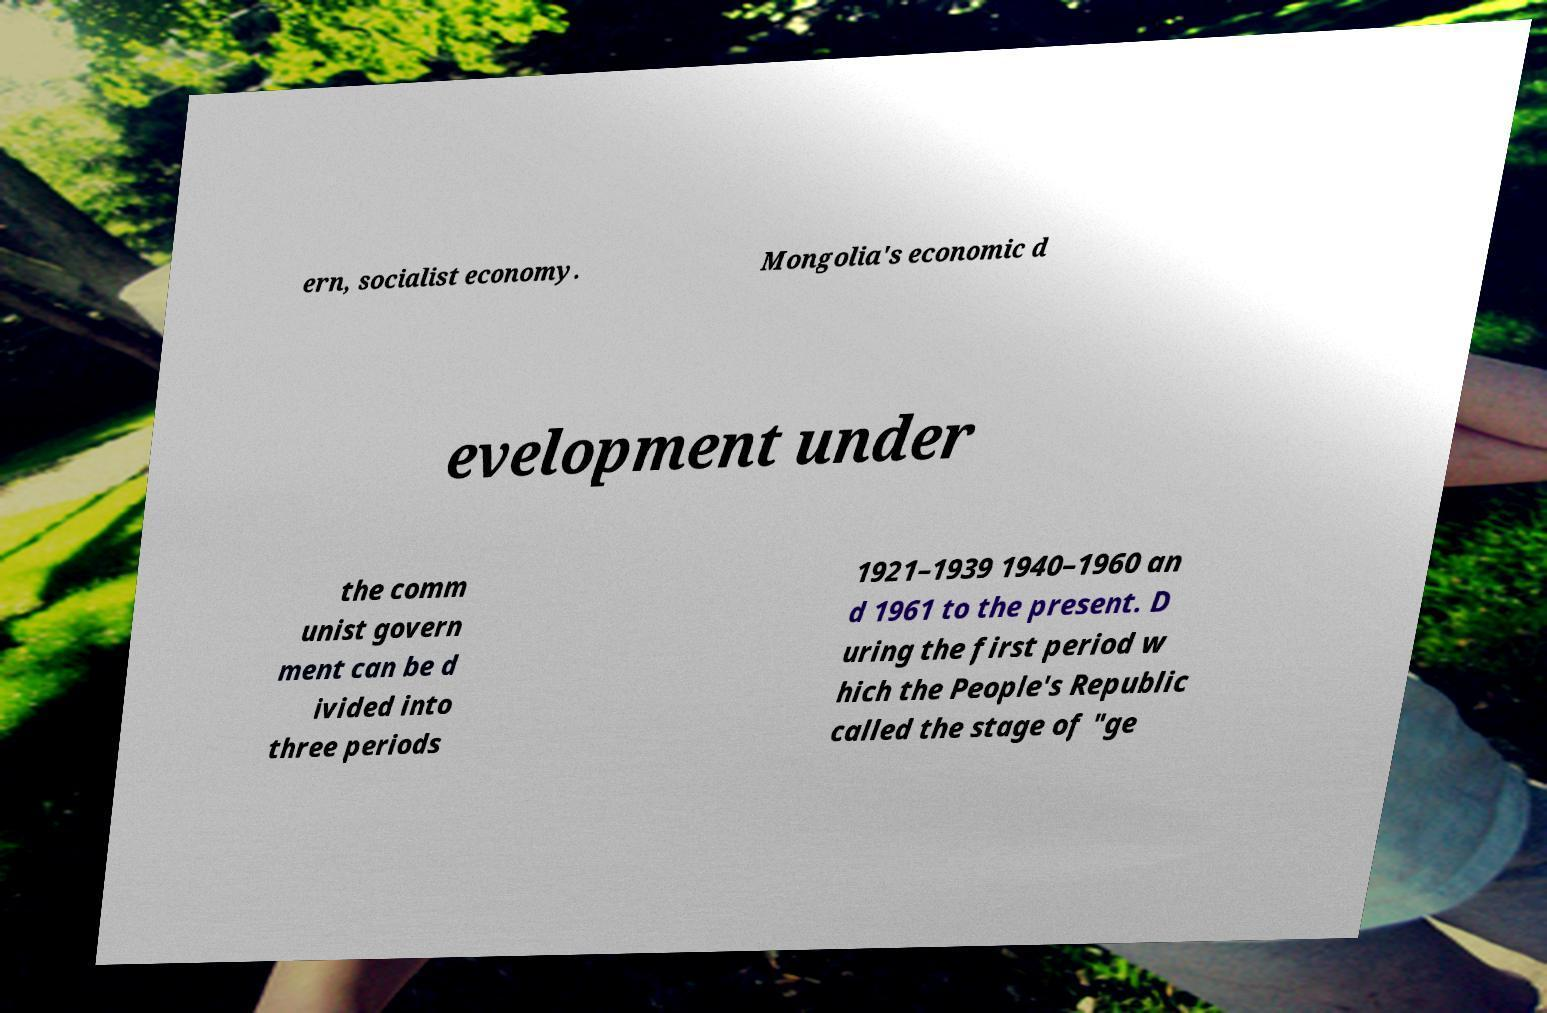There's text embedded in this image that I need extracted. Can you transcribe it verbatim? ern, socialist economy. Mongolia's economic d evelopment under the comm unist govern ment can be d ivided into three periods 1921–1939 1940–1960 an d 1961 to the present. D uring the first period w hich the People's Republic called the stage of "ge 